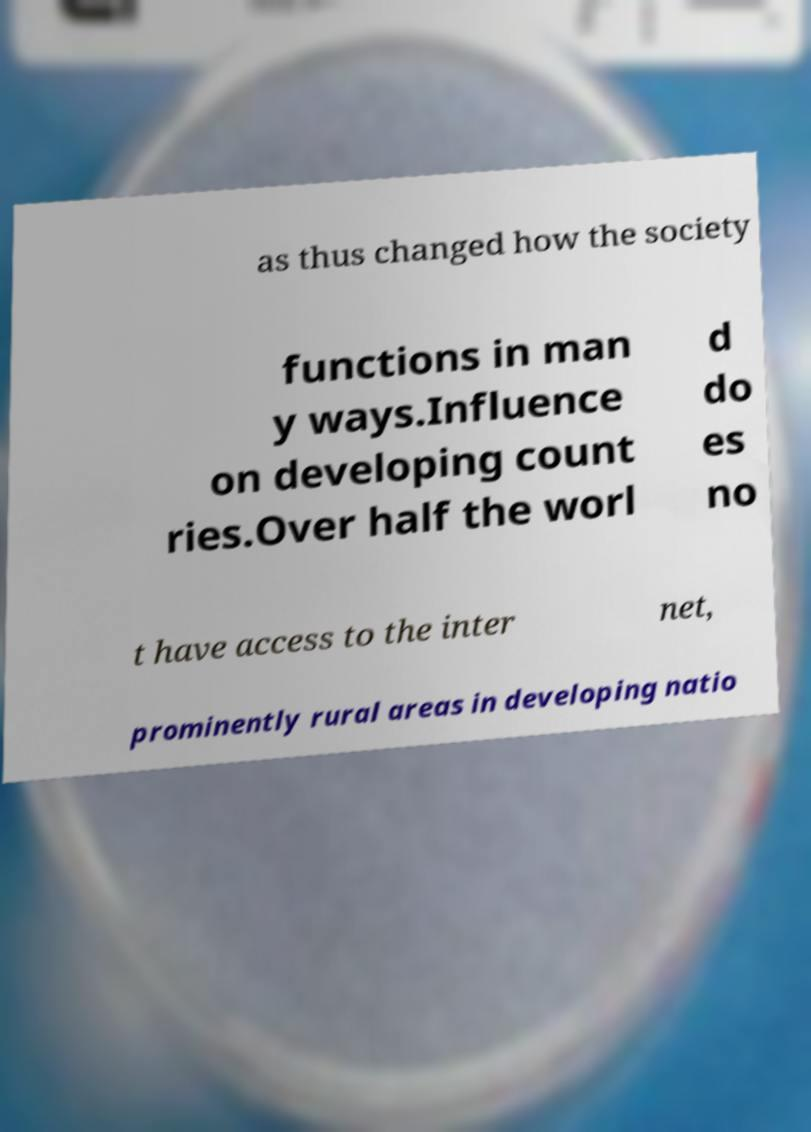Can you read and provide the text displayed in the image?This photo seems to have some interesting text. Can you extract and type it out for me? as thus changed how the society functions in man y ways.Influence on developing count ries.Over half the worl d do es no t have access to the inter net, prominently rural areas in developing natio 